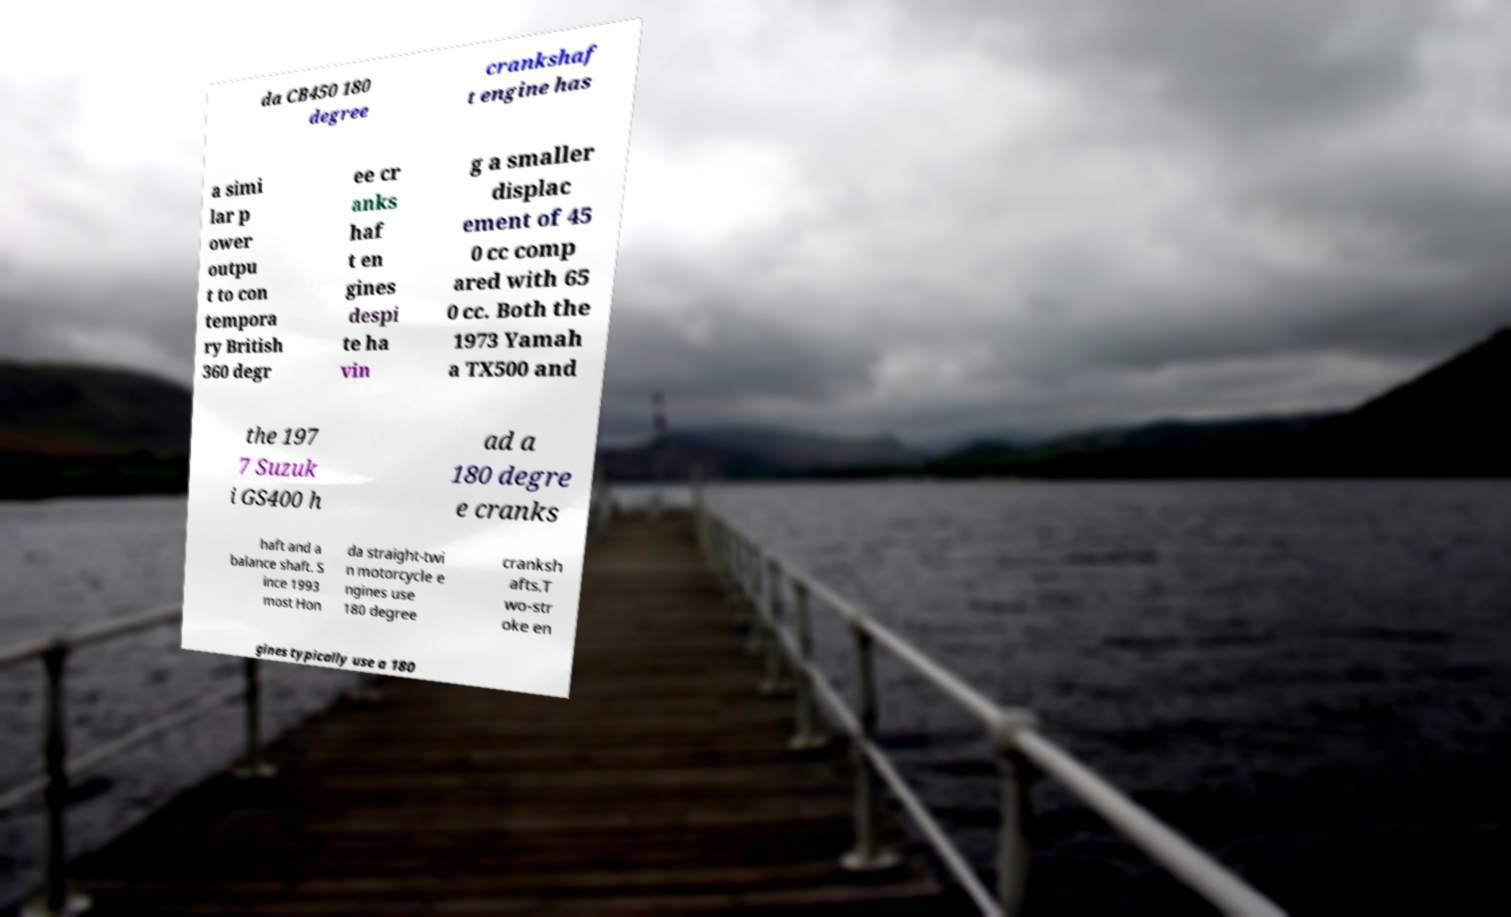There's text embedded in this image that I need extracted. Can you transcribe it verbatim? da CB450 180 degree crankshaf t engine has a simi lar p ower outpu t to con tempora ry British 360 degr ee cr anks haf t en gines despi te ha vin g a smaller displac ement of 45 0 cc comp ared with 65 0 cc. Both the 1973 Yamah a TX500 and the 197 7 Suzuk i GS400 h ad a 180 degre e cranks haft and a balance shaft. S ince 1993 most Hon da straight-twi n motorcycle e ngines use 180 degree cranksh afts.T wo-str oke en gines typically use a 180 